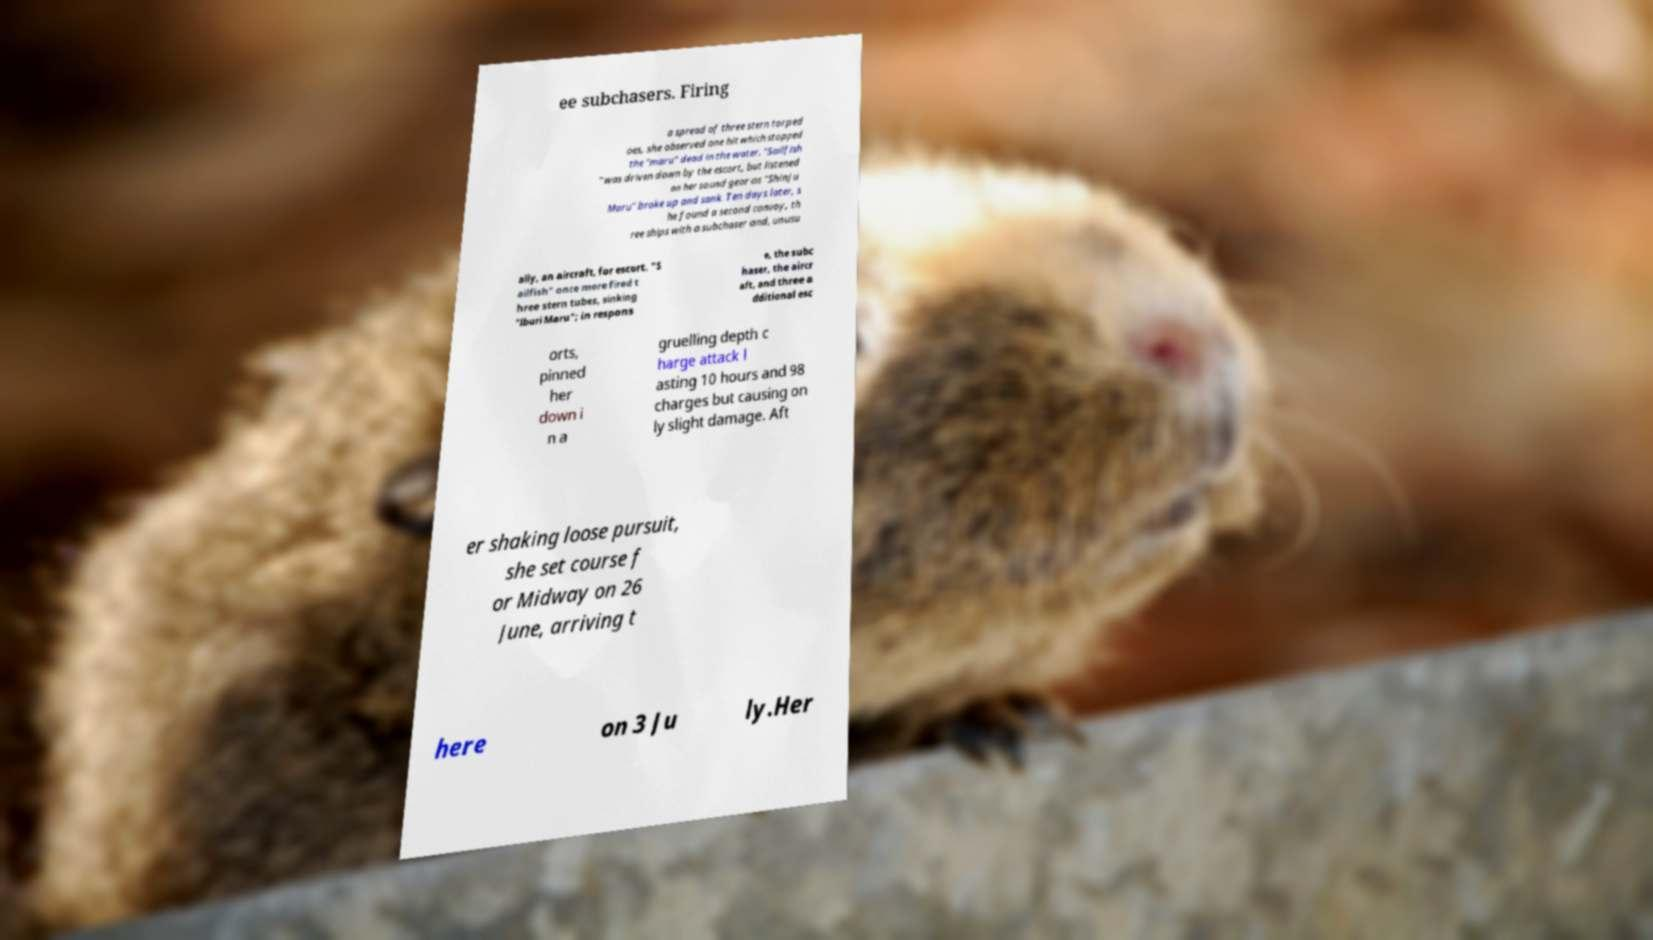Please identify and transcribe the text found in this image. ee subchasers. Firing a spread of three stern torped oes, she observed one hit which stopped the "maru" dead in the water. "Sailfish " was driven down by the escort, but listened on her sound gear as "Shinju Maru" broke up and sank. Ten days later, s he found a second convoy, th ree ships with a subchaser and, unusu ally, an aircraft, for escort. "S ailfish" once more fired t hree stern tubes, sinking "Iburi Maru"; in respons e, the subc haser, the aircr aft, and three a dditional esc orts, pinned her down i n a gruelling depth c harge attack l asting 10 hours and 98 charges but causing on ly slight damage. Aft er shaking loose pursuit, she set course f or Midway on 26 June, arriving t here on 3 Ju ly.Her 